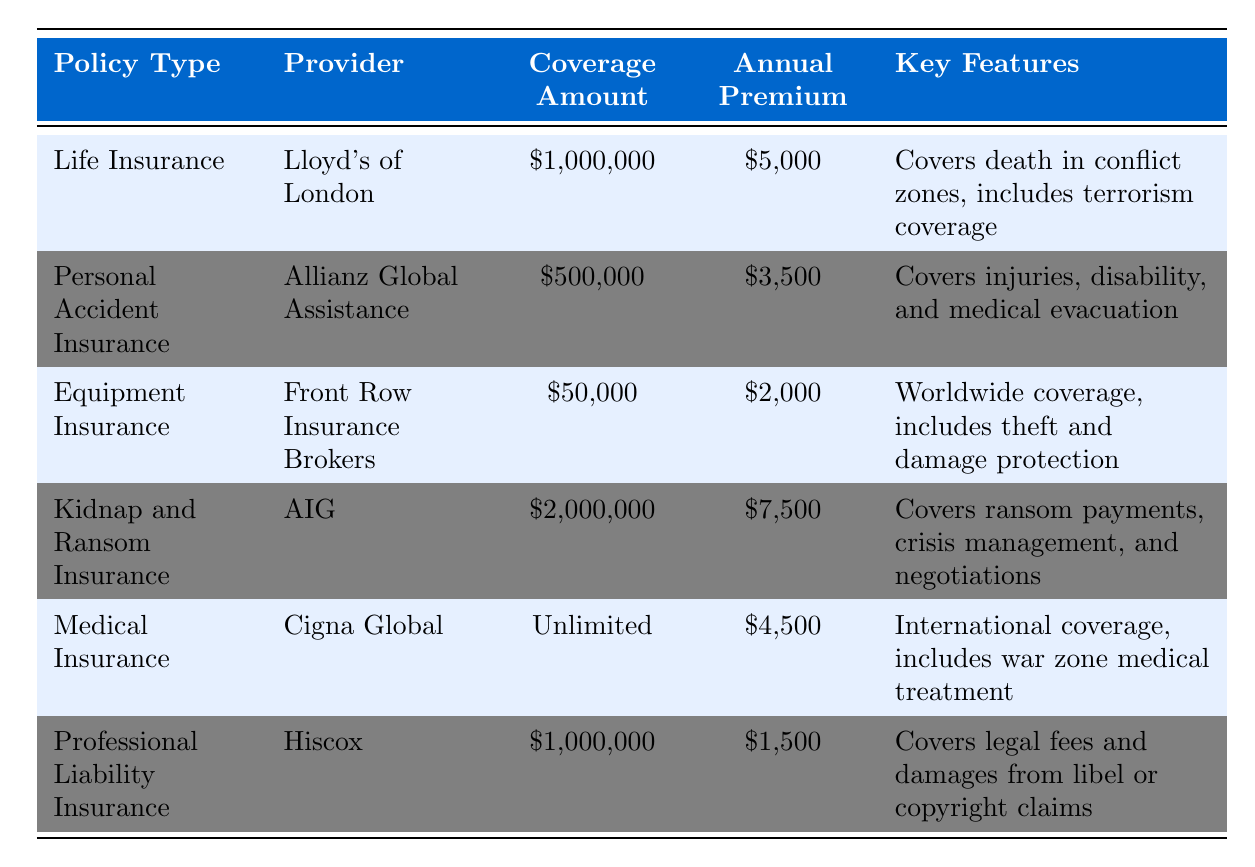What is the coverage amount for Kidnap and Ransom Insurance? The table lists the coverage amount specifically for Kidnap and Ransom Insurance, which is $2,000,000.
Answer: $2,000,000 Which provider offers Medical Insurance for war photographers? The table states that Cigna Global is the provider that offers Medical Insurance.
Answer: Cigna Global How much do you need to pay annually for Professional Liability Insurance? The table shows that the annual premium for Professional Liability Insurance is $1,500.
Answer: $1,500 What is the total coverage amount for Life Insurance and Personal Accident Insurance combined? The coverage amounts for Life Insurance and Personal Accident Insurance are $1,000,000 and $500,000, respectively. Adding these gives $1,000,000 + $500,000 = $1,500,000.
Answer: $1,500,000 Is Equipment Insurance provided by a company that also covers kidnap and ransom? The table indicates that Equipment Insurance is provided by Front Row Insurance Brokers, while Kidnap and Ransom Insurance is provided by AIG. These are different providers, so the answer is no.
Answer: No What is the difference in annual premiums between the most expensive and the least expensive insurance policies? The most expensive policy is Kidnap and Ransom Insurance at $7,500, and the least expensive is Professional Liability Insurance at $1,500. The difference is $7,500 - $1,500 = $6,000.
Answer: $6,000 Which insurance policy covers injuries and medical evacuation? The table states that Personal Accident Insurance covers injuries, disability, and medical evacuation.
Answer: Personal Accident Insurance What percentage of the coverage amount for Medical Insurance is unlimited compared to the highest fixed coverage amount offered? The highest fixed coverage amount is $2,000,000 (Kidnap and Ransom Insurance). Since Medical Insurance is unlimited, it surpasses this amount, meaning the percentage is theoretically infinite.
Answer: Infinite Which policy has the lowest annual premium? By reviewing the annual premiums, it is clear that Professional Liability Insurance at $1,500 has the lowest premium.
Answer: $1,500 If a war photographer selected all of the insurances except Equipment Insurance, what would their total annual premium be? The premiums for the selected policies (Life, Personal Accident, Kidnap and Ransom, Medical, and Professional Liability) are $5,000, $3,500, $7,500, $4,500, and $1,500. Adding these: $5,000 + $3,500 + $7,500 + $4,500 + $1,500 = $22,000.
Answer: $22,000 